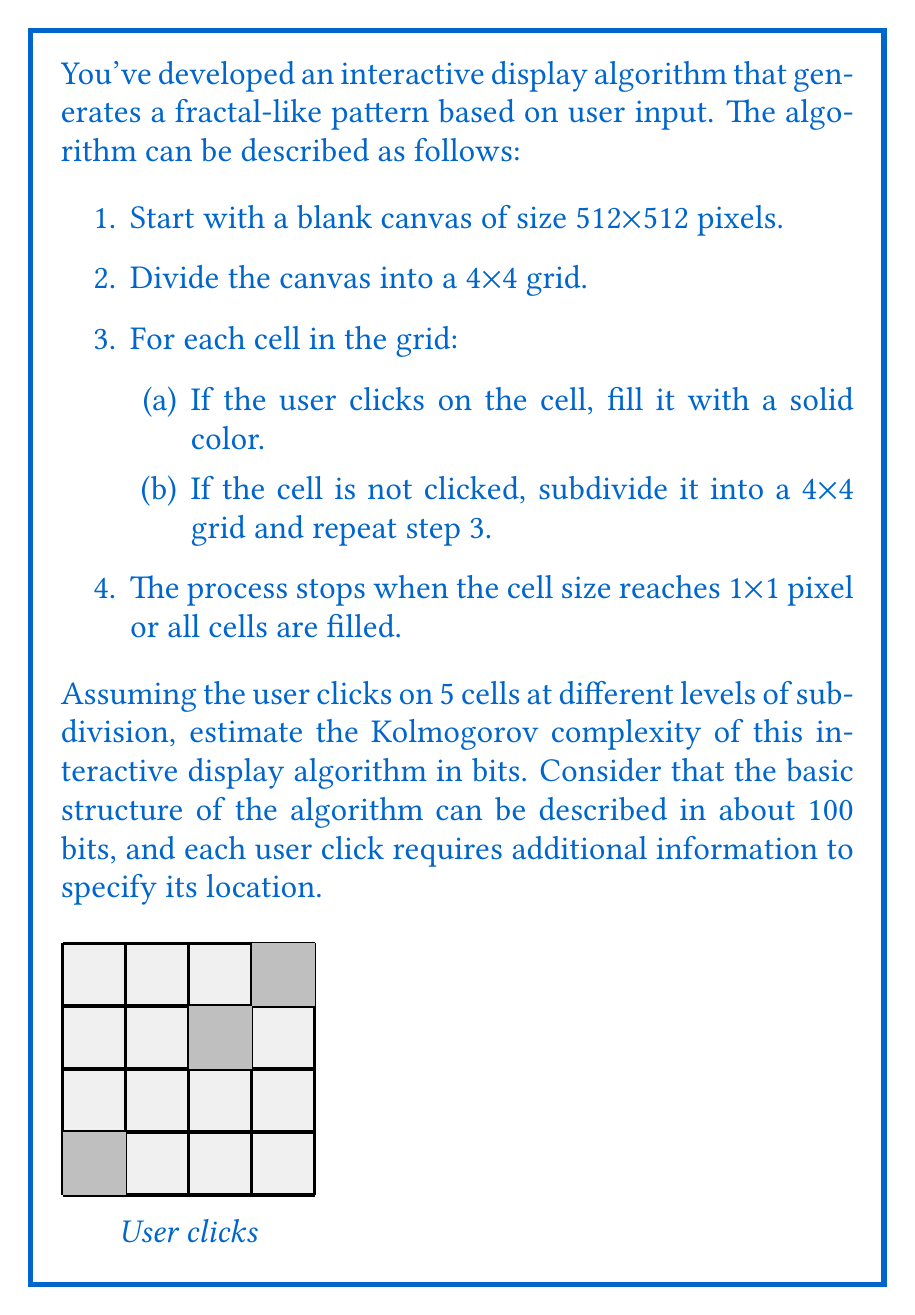Help me with this question. To estimate the Kolmogorov complexity of this interactive display algorithm, we need to consider the following components:

1. Basic algorithm structure: Given as 100 bits.

2. User clicks: We need to encode the location of each click. The canvas is 512x512 pixels, which requires $\log_2(512) = 9$ bits for each coordinate (x and y). However, due to the hierarchical nature of the subdivision, we can use fewer bits for higher-level clicks.

Let's assume the 5 clicks are distributed as follows:
- 1 click at the top level (4x4 grid): $\log_2(16) = 4$ bits
- 2 clicks at the second level (16x16 grid): $\log_2(256) = 8$ bits each
- 2 clicks at the third level (64x64 grid): $\log_2(4096) = 12$ bits each

3. Encoding of subdivision levels: We need to specify which level each click occurs at. With 5 clicks and a maximum of 9 levels (512/4 = 128, which requires 7 subdivision steps plus the initial and final states), we can use $\log_2(9) \approx 3.17$ bits per click, rounded up to 4 bits.

Now, let's calculate the total Kolmogorov complexity:

$$\begin{align*}
K &= \text{Basic algorithm} + \text{Click locations} + \text{Subdivision levels} \\
&= 100 + (4 + 8 + 8 + 12 + 12) + (4 * 5) \\
&= 100 + 44 + 20 \\
&= 164 \text{ bits}
\end{align*}$$

This estimation assumes optimal encoding and doesn't account for potential compression of repeating patterns. In practice, the actual Kolmogorov complexity might be slightly higher due to the need for a universal Turing machine to interpret the encoding.
Answer: $164$ bits 